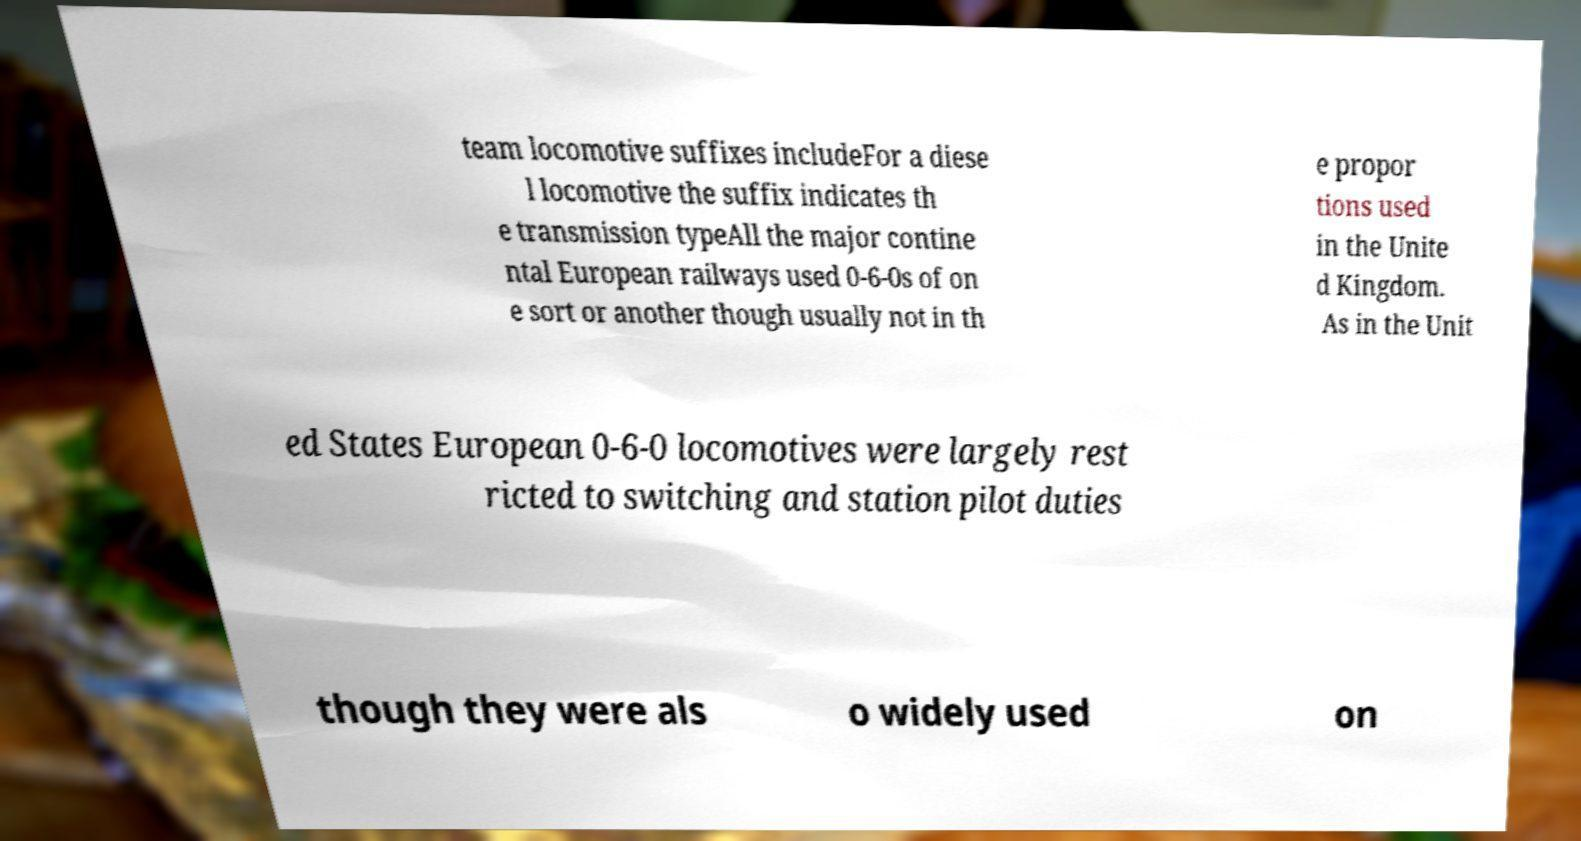Could you extract and type out the text from this image? team locomotive suffixes includeFor a diese l locomotive the suffix indicates th e transmission typeAll the major contine ntal European railways used 0-6-0s of on e sort or another though usually not in th e propor tions used in the Unite d Kingdom. As in the Unit ed States European 0-6-0 locomotives were largely rest ricted to switching and station pilot duties though they were als o widely used on 